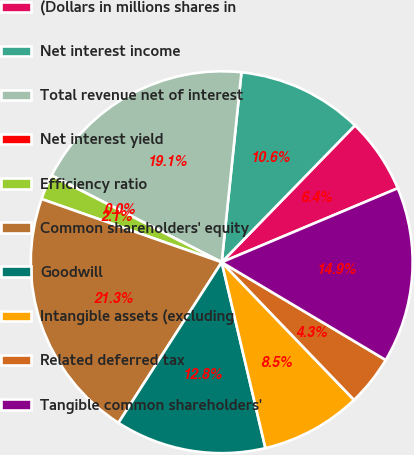Convert chart to OTSL. <chart><loc_0><loc_0><loc_500><loc_500><pie_chart><fcel>(Dollars in millions shares in<fcel>Net interest income<fcel>Total revenue net of interest<fcel>Net interest yield<fcel>Efficiency ratio<fcel>Common shareholders' equity<fcel>Goodwill<fcel>Intangible assets (excluding<fcel>Related deferred tax<fcel>Tangible common shareholders'<nl><fcel>6.38%<fcel>10.64%<fcel>19.15%<fcel>0.0%<fcel>2.13%<fcel>21.28%<fcel>12.77%<fcel>8.51%<fcel>4.26%<fcel>14.89%<nl></chart> 